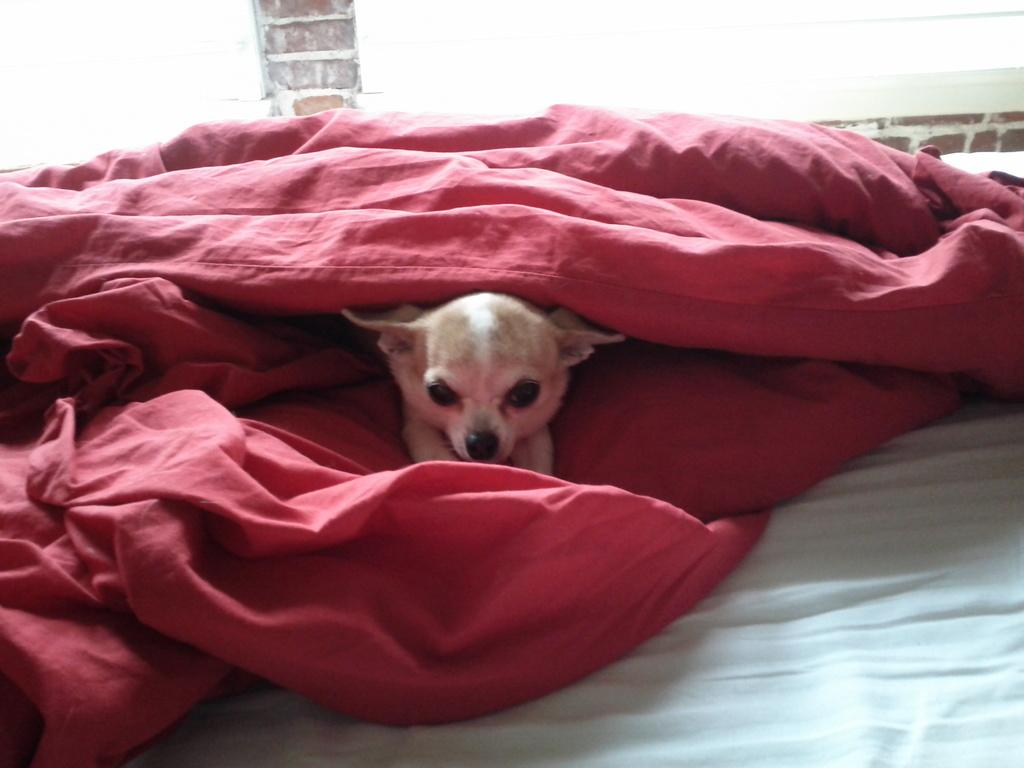What type of animal is in the image? There is a dog in the image. Can you describe the dog's coloring? The dog has cream, brown, and black coloring. What is covering the dog in the image? There is a red cloth around the dog. What color is the background of the image? The background of the image is white. Who is the mother of the dog in the image? There is no indication of a mother in the image, as it only features a dog with a red cloth around it. 